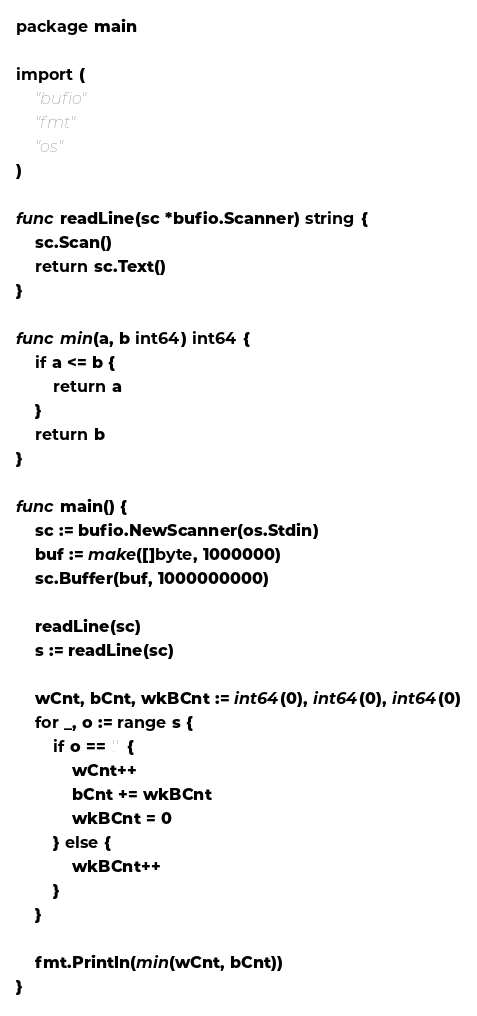Convert code to text. <code><loc_0><loc_0><loc_500><loc_500><_Go_>package main

import (
	"bufio"
	"fmt"
	"os"
)

func readLine(sc *bufio.Scanner) string {
	sc.Scan()
	return sc.Text()
}

func min(a, b int64) int64 {
	if a <= b {
		return a
	}
	return b
}

func main() {
	sc := bufio.NewScanner(os.Stdin)
	buf := make([]byte, 1000000)
	sc.Buffer(buf, 1000000000)

	readLine(sc)
	s := readLine(sc)

	wCnt, bCnt, wkBCnt := int64(0), int64(0), int64(0)
	for _, o := range s {
		if o == '.' {
			wCnt++
			bCnt += wkBCnt
			wkBCnt = 0
		} else {
			wkBCnt++
		}
	}

	fmt.Println(min(wCnt, bCnt))
}
</code> 